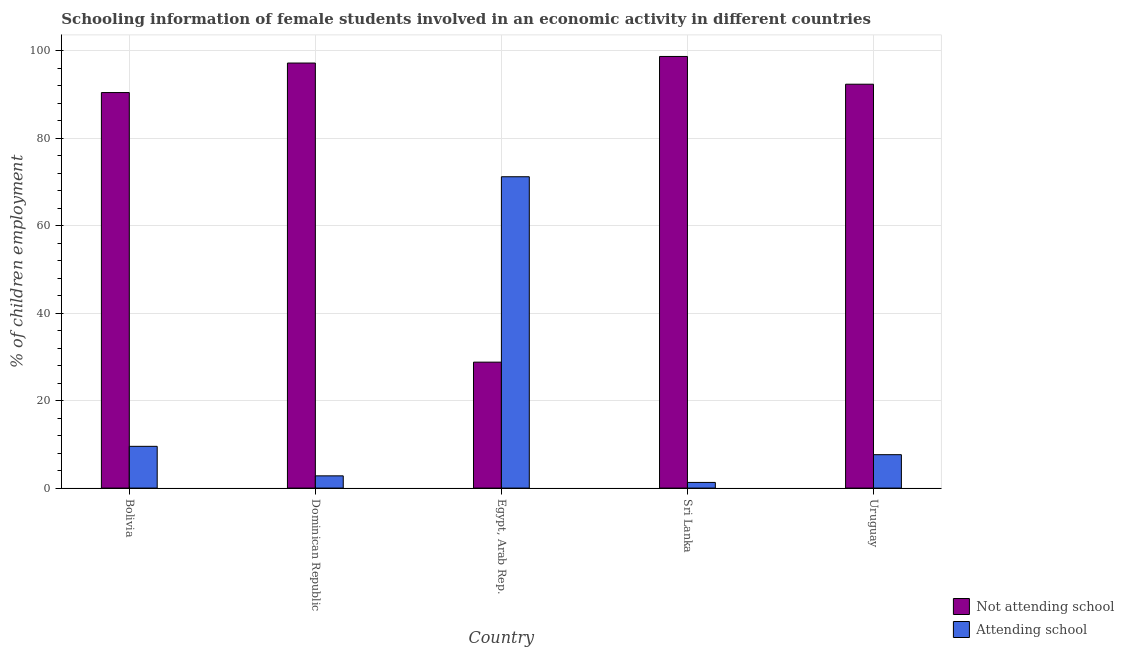How many different coloured bars are there?
Ensure brevity in your answer.  2. How many groups of bars are there?
Ensure brevity in your answer.  5. Are the number of bars on each tick of the X-axis equal?
Make the answer very short. Yes. How many bars are there on the 1st tick from the right?
Provide a succinct answer. 2. What is the label of the 1st group of bars from the left?
Your answer should be compact. Bolivia. In how many cases, is the number of bars for a given country not equal to the number of legend labels?
Offer a terse response. 0. What is the percentage of employed females who are attending school in Egypt, Arab Rep.?
Your answer should be compact. 71.2. Across all countries, what is the maximum percentage of employed females who are not attending school?
Ensure brevity in your answer.  98.71. Across all countries, what is the minimum percentage of employed females who are attending school?
Provide a succinct answer. 1.29. In which country was the percentage of employed females who are attending school maximum?
Your answer should be very brief. Egypt, Arab Rep. In which country was the percentage of employed females who are attending school minimum?
Ensure brevity in your answer.  Sri Lanka. What is the total percentage of employed females who are attending school in the graph?
Your response must be concise. 92.48. What is the difference between the percentage of employed females who are not attending school in Egypt, Arab Rep. and that in Uruguay?
Offer a very short reply. -63.56. What is the difference between the percentage of employed females who are not attending school in Bolivia and the percentage of employed females who are attending school in Sri Lanka?
Keep it short and to the point. 89.16. What is the average percentage of employed females who are not attending school per country?
Provide a succinct answer. 81.5. What is the difference between the percentage of employed females who are not attending school and percentage of employed females who are attending school in Bolivia?
Keep it short and to the point. 80.9. In how many countries, is the percentage of employed females who are attending school greater than 40 %?
Make the answer very short. 1. What is the ratio of the percentage of employed females who are not attending school in Egypt, Arab Rep. to that in Uruguay?
Make the answer very short. 0.31. What is the difference between the highest and the second highest percentage of employed females who are not attending school?
Your response must be concise. 1.51. What is the difference between the highest and the lowest percentage of employed females who are not attending school?
Offer a very short reply. 69.91. What does the 2nd bar from the left in Dominican Republic represents?
Give a very brief answer. Attending school. What does the 1st bar from the right in Bolivia represents?
Provide a succinct answer. Attending school. Are all the bars in the graph horizontal?
Give a very brief answer. No. Are the values on the major ticks of Y-axis written in scientific E-notation?
Provide a short and direct response. No. How many legend labels are there?
Provide a succinct answer. 2. How are the legend labels stacked?
Keep it short and to the point. Vertical. What is the title of the graph?
Give a very brief answer. Schooling information of female students involved in an economic activity in different countries. What is the label or title of the Y-axis?
Your answer should be compact. % of children employment. What is the % of children employment in Not attending school in Bolivia?
Ensure brevity in your answer.  90.45. What is the % of children employment in Attending school in Bolivia?
Offer a terse response. 9.55. What is the % of children employment of Not attending school in Dominican Republic?
Make the answer very short. 97.2. What is the % of children employment of Not attending school in Egypt, Arab Rep.?
Give a very brief answer. 28.8. What is the % of children employment of Attending school in Egypt, Arab Rep.?
Your answer should be very brief. 71.2. What is the % of children employment in Not attending school in Sri Lanka?
Offer a terse response. 98.71. What is the % of children employment of Attending school in Sri Lanka?
Make the answer very short. 1.29. What is the % of children employment of Not attending school in Uruguay?
Your response must be concise. 92.36. What is the % of children employment of Attending school in Uruguay?
Offer a terse response. 7.64. Across all countries, what is the maximum % of children employment in Not attending school?
Your answer should be very brief. 98.71. Across all countries, what is the maximum % of children employment in Attending school?
Your answer should be compact. 71.2. Across all countries, what is the minimum % of children employment of Not attending school?
Give a very brief answer. 28.8. Across all countries, what is the minimum % of children employment of Attending school?
Provide a succinct answer. 1.29. What is the total % of children employment in Not attending school in the graph?
Your response must be concise. 407.52. What is the total % of children employment of Attending school in the graph?
Your response must be concise. 92.48. What is the difference between the % of children employment of Not attending school in Bolivia and that in Dominican Republic?
Ensure brevity in your answer.  -6.75. What is the difference between the % of children employment of Attending school in Bolivia and that in Dominican Republic?
Your answer should be compact. 6.75. What is the difference between the % of children employment of Not attending school in Bolivia and that in Egypt, Arab Rep.?
Give a very brief answer. 61.65. What is the difference between the % of children employment in Attending school in Bolivia and that in Egypt, Arab Rep.?
Offer a terse response. -61.65. What is the difference between the % of children employment in Not attending school in Bolivia and that in Sri Lanka?
Give a very brief answer. -8.25. What is the difference between the % of children employment of Attending school in Bolivia and that in Sri Lanka?
Offer a very short reply. 8.25. What is the difference between the % of children employment of Not attending school in Bolivia and that in Uruguay?
Give a very brief answer. -1.91. What is the difference between the % of children employment of Attending school in Bolivia and that in Uruguay?
Offer a very short reply. 1.91. What is the difference between the % of children employment in Not attending school in Dominican Republic and that in Egypt, Arab Rep.?
Your answer should be very brief. 68.4. What is the difference between the % of children employment of Attending school in Dominican Republic and that in Egypt, Arab Rep.?
Offer a terse response. -68.4. What is the difference between the % of children employment of Not attending school in Dominican Republic and that in Sri Lanka?
Keep it short and to the point. -1.5. What is the difference between the % of children employment in Attending school in Dominican Republic and that in Sri Lanka?
Your answer should be very brief. 1.5. What is the difference between the % of children employment in Not attending school in Dominican Republic and that in Uruguay?
Offer a terse response. 4.84. What is the difference between the % of children employment in Attending school in Dominican Republic and that in Uruguay?
Your response must be concise. -4.84. What is the difference between the % of children employment in Not attending school in Egypt, Arab Rep. and that in Sri Lanka?
Provide a short and direct response. -69.91. What is the difference between the % of children employment of Attending school in Egypt, Arab Rep. and that in Sri Lanka?
Keep it short and to the point. 69.91. What is the difference between the % of children employment in Not attending school in Egypt, Arab Rep. and that in Uruguay?
Your response must be concise. -63.56. What is the difference between the % of children employment of Attending school in Egypt, Arab Rep. and that in Uruguay?
Offer a very short reply. 63.56. What is the difference between the % of children employment in Not attending school in Sri Lanka and that in Uruguay?
Give a very brief answer. 6.35. What is the difference between the % of children employment of Attending school in Sri Lanka and that in Uruguay?
Your answer should be compact. -6.35. What is the difference between the % of children employment of Not attending school in Bolivia and the % of children employment of Attending school in Dominican Republic?
Your answer should be compact. 87.65. What is the difference between the % of children employment in Not attending school in Bolivia and the % of children employment in Attending school in Egypt, Arab Rep.?
Provide a succinct answer. 19.25. What is the difference between the % of children employment in Not attending school in Bolivia and the % of children employment in Attending school in Sri Lanka?
Give a very brief answer. 89.16. What is the difference between the % of children employment of Not attending school in Bolivia and the % of children employment of Attending school in Uruguay?
Keep it short and to the point. 82.81. What is the difference between the % of children employment of Not attending school in Dominican Republic and the % of children employment of Attending school in Sri Lanka?
Provide a short and direct response. 95.91. What is the difference between the % of children employment in Not attending school in Dominican Republic and the % of children employment in Attending school in Uruguay?
Provide a short and direct response. 89.56. What is the difference between the % of children employment of Not attending school in Egypt, Arab Rep. and the % of children employment of Attending school in Sri Lanka?
Offer a terse response. 27.5. What is the difference between the % of children employment of Not attending school in Egypt, Arab Rep. and the % of children employment of Attending school in Uruguay?
Provide a short and direct response. 21.16. What is the difference between the % of children employment in Not attending school in Sri Lanka and the % of children employment in Attending school in Uruguay?
Provide a short and direct response. 91.06. What is the average % of children employment in Not attending school per country?
Give a very brief answer. 81.5. What is the average % of children employment in Attending school per country?
Make the answer very short. 18.5. What is the difference between the % of children employment in Not attending school and % of children employment in Attending school in Bolivia?
Your answer should be very brief. 80.9. What is the difference between the % of children employment in Not attending school and % of children employment in Attending school in Dominican Republic?
Provide a short and direct response. 94.4. What is the difference between the % of children employment of Not attending school and % of children employment of Attending school in Egypt, Arab Rep.?
Give a very brief answer. -42.4. What is the difference between the % of children employment of Not attending school and % of children employment of Attending school in Sri Lanka?
Offer a terse response. 97.41. What is the difference between the % of children employment in Not attending school and % of children employment in Attending school in Uruguay?
Provide a succinct answer. 84.72. What is the ratio of the % of children employment of Not attending school in Bolivia to that in Dominican Republic?
Ensure brevity in your answer.  0.93. What is the ratio of the % of children employment in Attending school in Bolivia to that in Dominican Republic?
Your response must be concise. 3.41. What is the ratio of the % of children employment of Not attending school in Bolivia to that in Egypt, Arab Rep.?
Provide a succinct answer. 3.14. What is the ratio of the % of children employment of Attending school in Bolivia to that in Egypt, Arab Rep.?
Your answer should be compact. 0.13. What is the ratio of the % of children employment in Not attending school in Bolivia to that in Sri Lanka?
Your response must be concise. 0.92. What is the ratio of the % of children employment of Attending school in Bolivia to that in Sri Lanka?
Keep it short and to the point. 7.37. What is the ratio of the % of children employment of Not attending school in Bolivia to that in Uruguay?
Provide a succinct answer. 0.98. What is the ratio of the % of children employment of Attending school in Bolivia to that in Uruguay?
Offer a terse response. 1.25. What is the ratio of the % of children employment of Not attending school in Dominican Republic to that in Egypt, Arab Rep.?
Your answer should be very brief. 3.38. What is the ratio of the % of children employment in Attending school in Dominican Republic to that in Egypt, Arab Rep.?
Offer a terse response. 0.04. What is the ratio of the % of children employment of Attending school in Dominican Republic to that in Sri Lanka?
Your answer should be compact. 2.16. What is the ratio of the % of children employment of Not attending school in Dominican Republic to that in Uruguay?
Provide a succinct answer. 1.05. What is the ratio of the % of children employment in Attending school in Dominican Republic to that in Uruguay?
Give a very brief answer. 0.37. What is the ratio of the % of children employment of Not attending school in Egypt, Arab Rep. to that in Sri Lanka?
Your answer should be compact. 0.29. What is the ratio of the % of children employment of Attending school in Egypt, Arab Rep. to that in Sri Lanka?
Your answer should be very brief. 54.98. What is the ratio of the % of children employment in Not attending school in Egypt, Arab Rep. to that in Uruguay?
Make the answer very short. 0.31. What is the ratio of the % of children employment of Attending school in Egypt, Arab Rep. to that in Uruguay?
Give a very brief answer. 9.32. What is the ratio of the % of children employment in Not attending school in Sri Lanka to that in Uruguay?
Provide a short and direct response. 1.07. What is the ratio of the % of children employment of Attending school in Sri Lanka to that in Uruguay?
Give a very brief answer. 0.17. What is the difference between the highest and the second highest % of children employment in Not attending school?
Ensure brevity in your answer.  1.5. What is the difference between the highest and the second highest % of children employment in Attending school?
Your answer should be compact. 61.65. What is the difference between the highest and the lowest % of children employment in Not attending school?
Ensure brevity in your answer.  69.91. What is the difference between the highest and the lowest % of children employment in Attending school?
Ensure brevity in your answer.  69.91. 